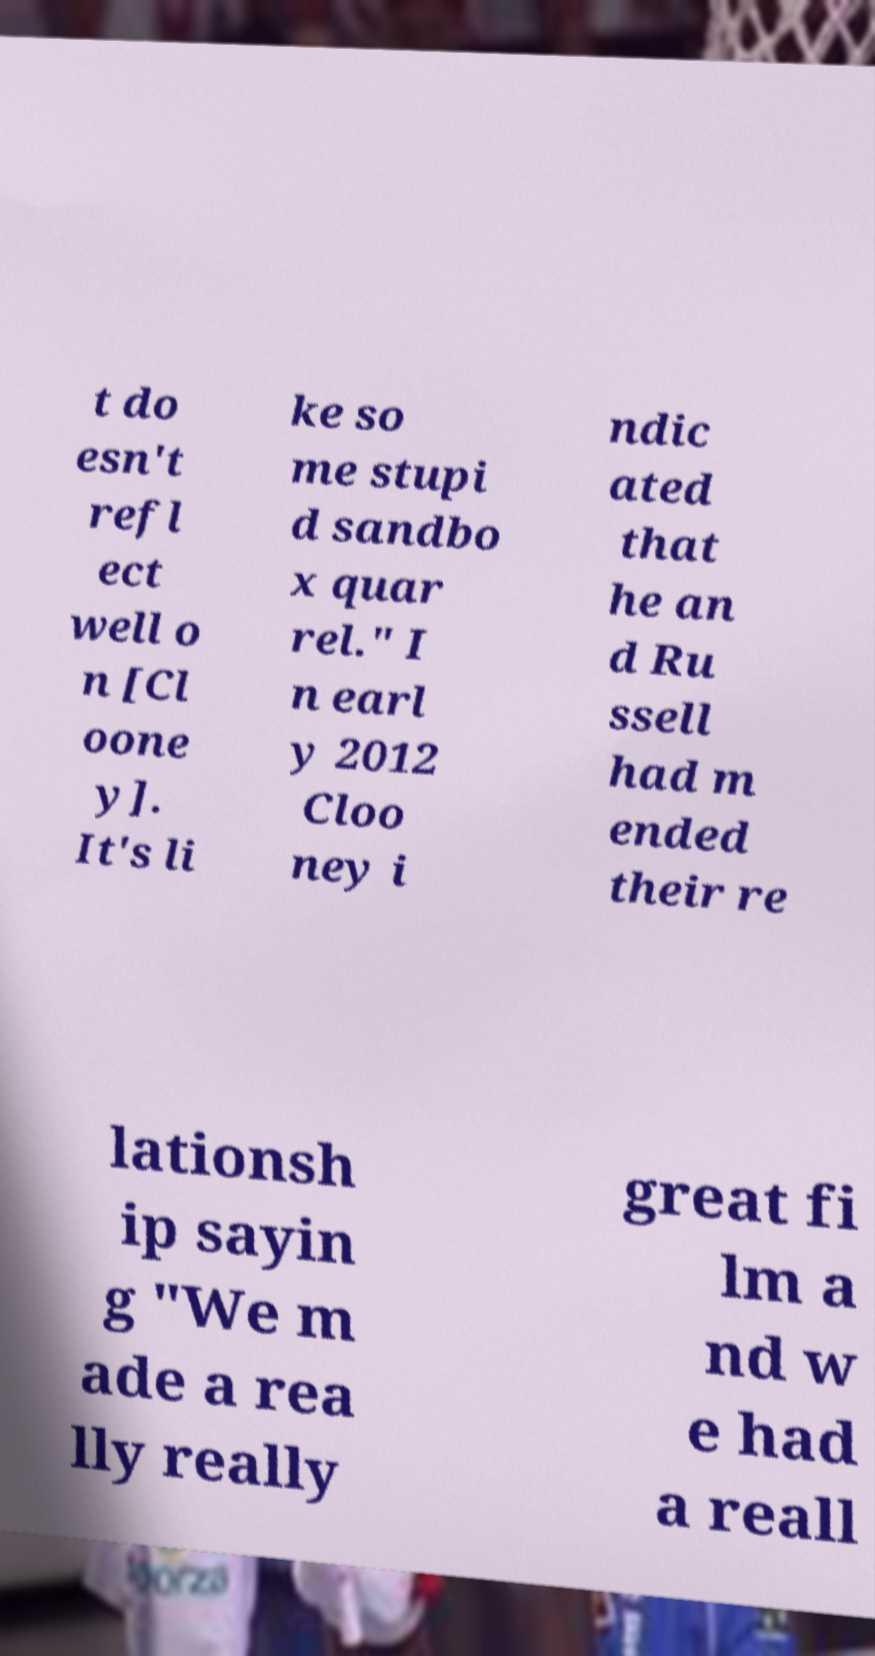Can you accurately transcribe the text from the provided image for me? t do esn't refl ect well o n [Cl oone y]. It's li ke so me stupi d sandbo x quar rel." I n earl y 2012 Cloo ney i ndic ated that he an d Ru ssell had m ended their re lationsh ip sayin g "We m ade a rea lly really great fi lm a nd w e had a reall 